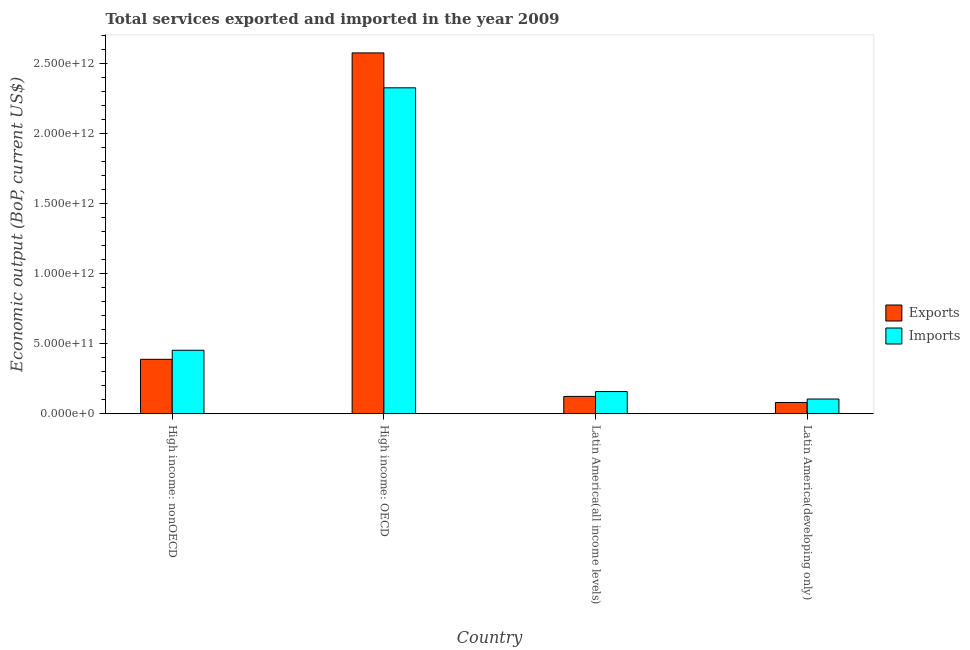How many different coloured bars are there?
Your response must be concise. 2. Are the number of bars on each tick of the X-axis equal?
Provide a short and direct response. Yes. How many bars are there on the 1st tick from the right?
Provide a succinct answer. 2. What is the label of the 2nd group of bars from the left?
Your answer should be very brief. High income: OECD. What is the amount of service imports in Latin America(all income levels)?
Offer a terse response. 1.58e+11. Across all countries, what is the maximum amount of service imports?
Give a very brief answer. 2.33e+12. Across all countries, what is the minimum amount of service exports?
Your answer should be compact. 8.02e+1. In which country was the amount of service exports maximum?
Keep it short and to the point. High income: OECD. In which country was the amount of service exports minimum?
Provide a short and direct response. Latin America(developing only). What is the total amount of service exports in the graph?
Your response must be concise. 3.17e+12. What is the difference between the amount of service exports in High income: nonOECD and that in Latin America(all income levels)?
Offer a terse response. 2.65e+11. What is the difference between the amount of service imports in Latin America(developing only) and the amount of service exports in High income: nonOECD?
Your answer should be compact. -2.83e+11. What is the average amount of service imports per country?
Your answer should be compact. 7.61e+11. What is the difference between the amount of service exports and amount of service imports in Latin America(developing only)?
Give a very brief answer. -2.49e+1. In how many countries, is the amount of service exports greater than 2200000000000 US$?
Ensure brevity in your answer.  1. What is the ratio of the amount of service exports in High income: OECD to that in Latin America(developing only)?
Provide a succinct answer. 32.11. Is the amount of service imports in High income: nonOECD less than that in Latin America(developing only)?
Offer a terse response. No. What is the difference between the highest and the second highest amount of service imports?
Make the answer very short. 1.87e+12. What is the difference between the highest and the lowest amount of service exports?
Your response must be concise. 2.50e+12. In how many countries, is the amount of service exports greater than the average amount of service exports taken over all countries?
Give a very brief answer. 1. Is the sum of the amount of service imports in High income: OECD and Latin America(developing only) greater than the maximum amount of service exports across all countries?
Your answer should be very brief. No. What does the 1st bar from the left in Latin America(all income levels) represents?
Your response must be concise. Exports. What does the 1st bar from the right in High income: nonOECD represents?
Your answer should be very brief. Imports. How many bars are there?
Give a very brief answer. 8. How many countries are there in the graph?
Provide a short and direct response. 4. What is the difference between two consecutive major ticks on the Y-axis?
Provide a succinct answer. 5.00e+11. Are the values on the major ticks of Y-axis written in scientific E-notation?
Your answer should be very brief. Yes. Where does the legend appear in the graph?
Your answer should be compact. Center right. How many legend labels are there?
Make the answer very short. 2. What is the title of the graph?
Provide a short and direct response. Total services exported and imported in the year 2009. What is the label or title of the X-axis?
Provide a short and direct response. Country. What is the label or title of the Y-axis?
Your answer should be very brief. Economic output (BoP, current US$). What is the Economic output (BoP, current US$) of Exports in High income: nonOECD?
Your answer should be very brief. 3.89e+11. What is the Economic output (BoP, current US$) in Imports in High income: nonOECD?
Keep it short and to the point. 4.53e+11. What is the Economic output (BoP, current US$) of Exports in High income: OECD?
Keep it short and to the point. 2.58e+12. What is the Economic output (BoP, current US$) in Imports in High income: OECD?
Provide a short and direct response. 2.33e+12. What is the Economic output (BoP, current US$) of Exports in Latin America(all income levels)?
Make the answer very short. 1.24e+11. What is the Economic output (BoP, current US$) in Imports in Latin America(all income levels)?
Give a very brief answer. 1.58e+11. What is the Economic output (BoP, current US$) in Exports in Latin America(developing only)?
Ensure brevity in your answer.  8.02e+1. What is the Economic output (BoP, current US$) of Imports in Latin America(developing only)?
Your answer should be very brief. 1.05e+11. Across all countries, what is the maximum Economic output (BoP, current US$) of Exports?
Offer a terse response. 2.58e+12. Across all countries, what is the maximum Economic output (BoP, current US$) in Imports?
Provide a short and direct response. 2.33e+12. Across all countries, what is the minimum Economic output (BoP, current US$) in Exports?
Your answer should be very brief. 8.02e+1. Across all countries, what is the minimum Economic output (BoP, current US$) in Imports?
Give a very brief answer. 1.05e+11. What is the total Economic output (BoP, current US$) in Exports in the graph?
Make the answer very short. 3.17e+12. What is the total Economic output (BoP, current US$) of Imports in the graph?
Offer a terse response. 3.04e+12. What is the difference between the Economic output (BoP, current US$) in Exports in High income: nonOECD and that in High income: OECD?
Provide a succinct answer. -2.19e+12. What is the difference between the Economic output (BoP, current US$) in Imports in High income: nonOECD and that in High income: OECD?
Provide a succinct answer. -1.87e+12. What is the difference between the Economic output (BoP, current US$) of Exports in High income: nonOECD and that in Latin America(all income levels)?
Your answer should be compact. 2.65e+11. What is the difference between the Economic output (BoP, current US$) in Imports in High income: nonOECD and that in Latin America(all income levels)?
Your response must be concise. 2.95e+11. What is the difference between the Economic output (BoP, current US$) in Exports in High income: nonOECD and that in Latin America(developing only)?
Your response must be concise. 3.08e+11. What is the difference between the Economic output (BoP, current US$) in Imports in High income: nonOECD and that in Latin America(developing only)?
Ensure brevity in your answer.  3.48e+11. What is the difference between the Economic output (BoP, current US$) of Exports in High income: OECD and that in Latin America(all income levels)?
Make the answer very short. 2.45e+12. What is the difference between the Economic output (BoP, current US$) of Imports in High income: OECD and that in Latin America(all income levels)?
Your response must be concise. 2.17e+12. What is the difference between the Economic output (BoP, current US$) of Exports in High income: OECD and that in Latin America(developing only)?
Ensure brevity in your answer.  2.50e+12. What is the difference between the Economic output (BoP, current US$) of Imports in High income: OECD and that in Latin America(developing only)?
Provide a succinct answer. 2.22e+12. What is the difference between the Economic output (BoP, current US$) in Exports in Latin America(all income levels) and that in Latin America(developing only)?
Make the answer very short. 4.35e+1. What is the difference between the Economic output (BoP, current US$) of Imports in Latin America(all income levels) and that in Latin America(developing only)?
Your response must be concise. 5.33e+1. What is the difference between the Economic output (BoP, current US$) of Exports in High income: nonOECD and the Economic output (BoP, current US$) of Imports in High income: OECD?
Keep it short and to the point. -1.94e+12. What is the difference between the Economic output (BoP, current US$) of Exports in High income: nonOECD and the Economic output (BoP, current US$) of Imports in Latin America(all income levels)?
Offer a terse response. 2.30e+11. What is the difference between the Economic output (BoP, current US$) of Exports in High income: nonOECD and the Economic output (BoP, current US$) of Imports in Latin America(developing only)?
Make the answer very short. 2.83e+11. What is the difference between the Economic output (BoP, current US$) in Exports in High income: OECD and the Economic output (BoP, current US$) in Imports in Latin America(all income levels)?
Your answer should be very brief. 2.42e+12. What is the difference between the Economic output (BoP, current US$) of Exports in High income: OECD and the Economic output (BoP, current US$) of Imports in Latin America(developing only)?
Offer a very short reply. 2.47e+12. What is the difference between the Economic output (BoP, current US$) in Exports in Latin America(all income levels) and the Economic output (BoP, current US$) in Imports in Latin America(developing only)?
Your response must be concise. 1.86e+1. What is the average Economic output (BoP, current US$) of Exports per country?
Keep it short and to the point. 7.92e+11. What is the average Economic output (BoP, current US$) of Imports per country?
Make the answer very short. 7.61e+11. What is the difference between the Economic output (BoP, current US$) in Exports and Economic output (BoP, current US$) in Imports in High income: nonOECD?
Offer a terse response. -6.47e+1. What is the difference between the Economic output (BoP, current US$) in Exports and Economic output (BoP, current US$) in Imports in High income: OECD?
Ensure brevity in your answer.  2.49e+11. What is the difference between the Economic output (BoP, current US$) in Exports and Economic output (BoP, current US$) in Imports in Latin America(all income levels)?
Your answer should be compact. -3.47e+1. What is the difference between the Economic output (BoP, current US$) in Exports and Economic output (BoP, current US$) in Imports in Latin America(developing only)?
Ensure brevity in your answer.  -2.49e+1. What is the ratio of the Economic output (BoP, current US$) of Exports in High income: nonOECD to that in High income: OECD?
Your answer should be very brief. 0.15. What is the ratio of the Economic output (BoP, current US$) in Imports in High income: nonOECD to that in High income: OECD?
Offer a terse response. 0.19. What is the ratio of the Economic output (BoP, current US$) of Exports in High income: nonOECD to that in Latin America(all income levels)?
Offer a terse response. 3.14. What is the ratio of the Economic output (BoP, current US$) in Imports in High income: nonOECD to that in Latin America(all income levels)?
Ensure brevity in your answer.  2.86. What is the ratio of the Economic output (BoP, current US$) of Exports in High income: nonOECD to that in Latin America(developing only)?
Give a very brief answer. 4.84. What is the ratio of the Economic output (BoP, current US$) of Imports in High income: nonOECD to that in Latin America(developing only)?
Provide a succinct answer. 4.31. What is the ratio of the Economic output (BoP, current US$) of Exports in High income: OECD to that in Latin America(all income levels)?
Make the answer very short. 20.83. What is the ratio of the Economic output (BoP, current US$) in Imports in High income: OECD to that in Latin America(all income levels)?
Your response must be concise. 14.7. What is the ratio of the Economic output (BoP, current US$) of Exports in High income: OECD to that in Latin America(developing only)?
Your answer should be compact. 32.11. What is the ratio of the Economic output (BoP, current US$) in Imports in High income: OECD to that in Latin America(developing only)?
Provide a succinct answer. 22.14. What is the ratio of the Economic output (BoP, current US$) in Exports in Latin America(all income levels) to that in Latin America(developing only)?
Offer a terse response. 1.54. What is the ratio of the Economic output (BoP, current US$) in Imports in Latin America(all income levels) to that in Latin America(developing only)?
Provide a short and direct response. 1.51. What is the difference between the highest and the second highest Economic output (BoP, current US$) of Exports?
Your answer should be compact. 2.19e+12. What is the difference between the highest and the second highest Economic output (BoP, current US$) of Imports?
Make the answer very short. 1.87e+12. What is the difference between the highest and the lowest Economic output (BoP, current US$) in Exports?
Your answer should be compact. 2.50e+12. What is the difference between the highest and the lowest Economic output (BoP, current US$) in Imports?
Your response must be concise. 2.22e+12. 